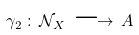Convert formula to latex. <formula><loc_0><loc_0><loc_500><loc_500>\gamma _ { 2 } \, \colon \, { \mathcal { N } } _ { X } \, \longrightarrow \, A</formula> 